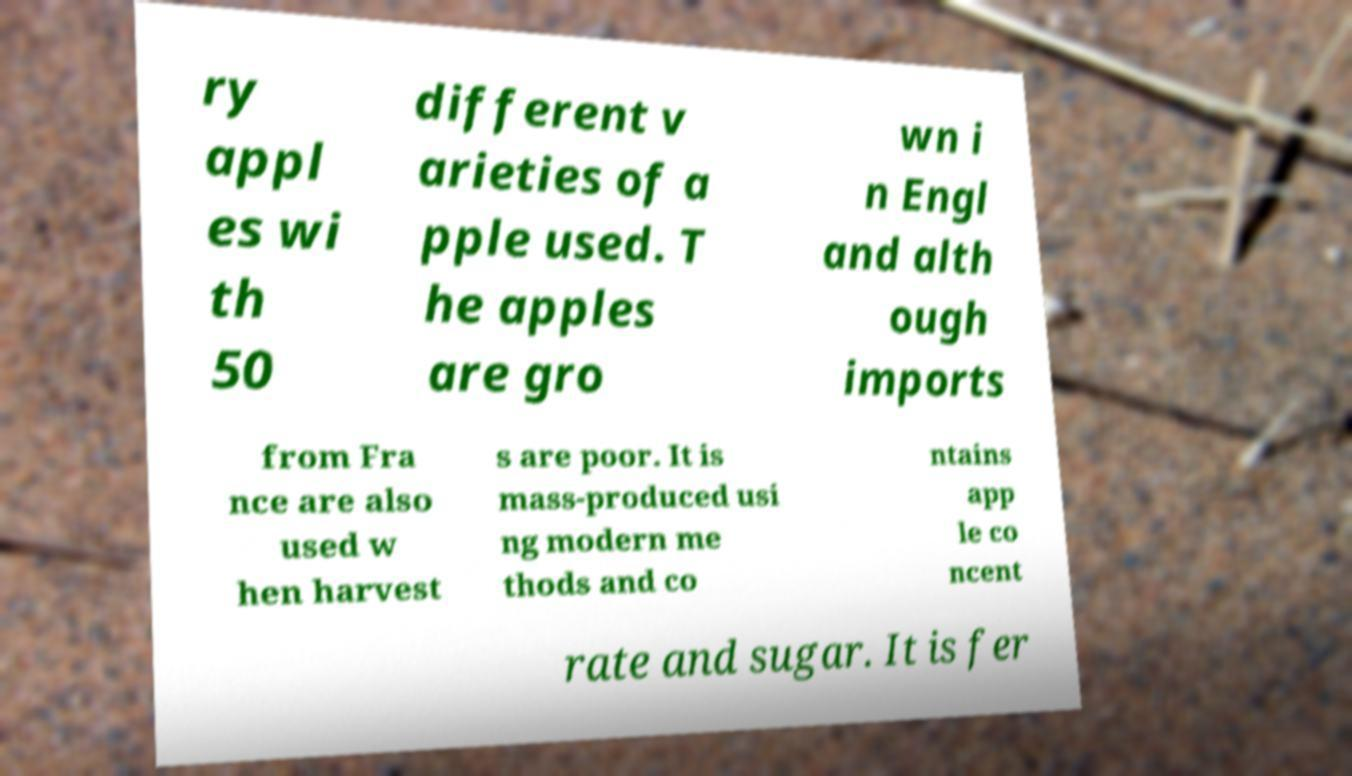Can you accurately transcribe the text from the provided image for me? ry appl es wi th 50 different v arieties of a pple used. T he apples are gro wn i n Engl and alth ough imports from Fra nce are also used w hen harvest s are poor. It is mass-produced usi ng modern me thods and co ntains app le co ncent rate and sugar. It is fer 